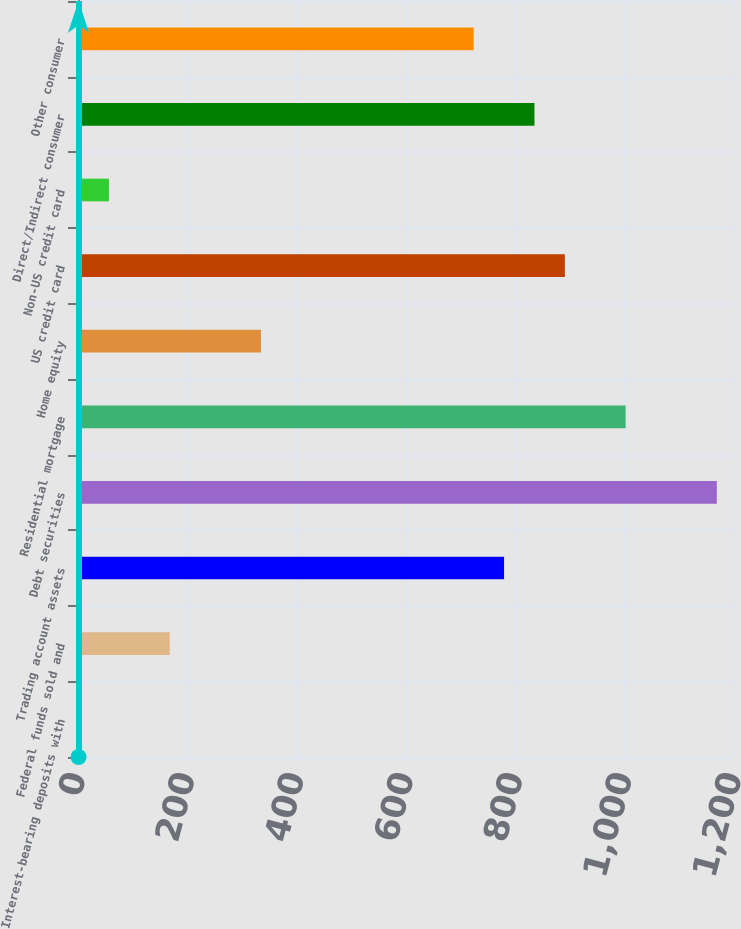Convert chart. <chart><loc_0><loc_0><loc_500><loc_500><bar_chart><fcel>Interest-bearing deposits with<fcel>Federal funds sold and<fcel>Trading account assets<fcel>Debt securities<fcel>Residential mortgage<fcel>Home equity<fcel>US credit card<fcel>Non-US credit card<fcel>Direct/Indirect consumer<fcel>Other consumer<nl><fcel>1<fcel>167.8<fcel>779.4<fcel>1168.6<fcel>1001.8<fcel>334.6<fcel>890.6<fcel>56.6<fcel>835<fcel>723.8<nl></chart> 